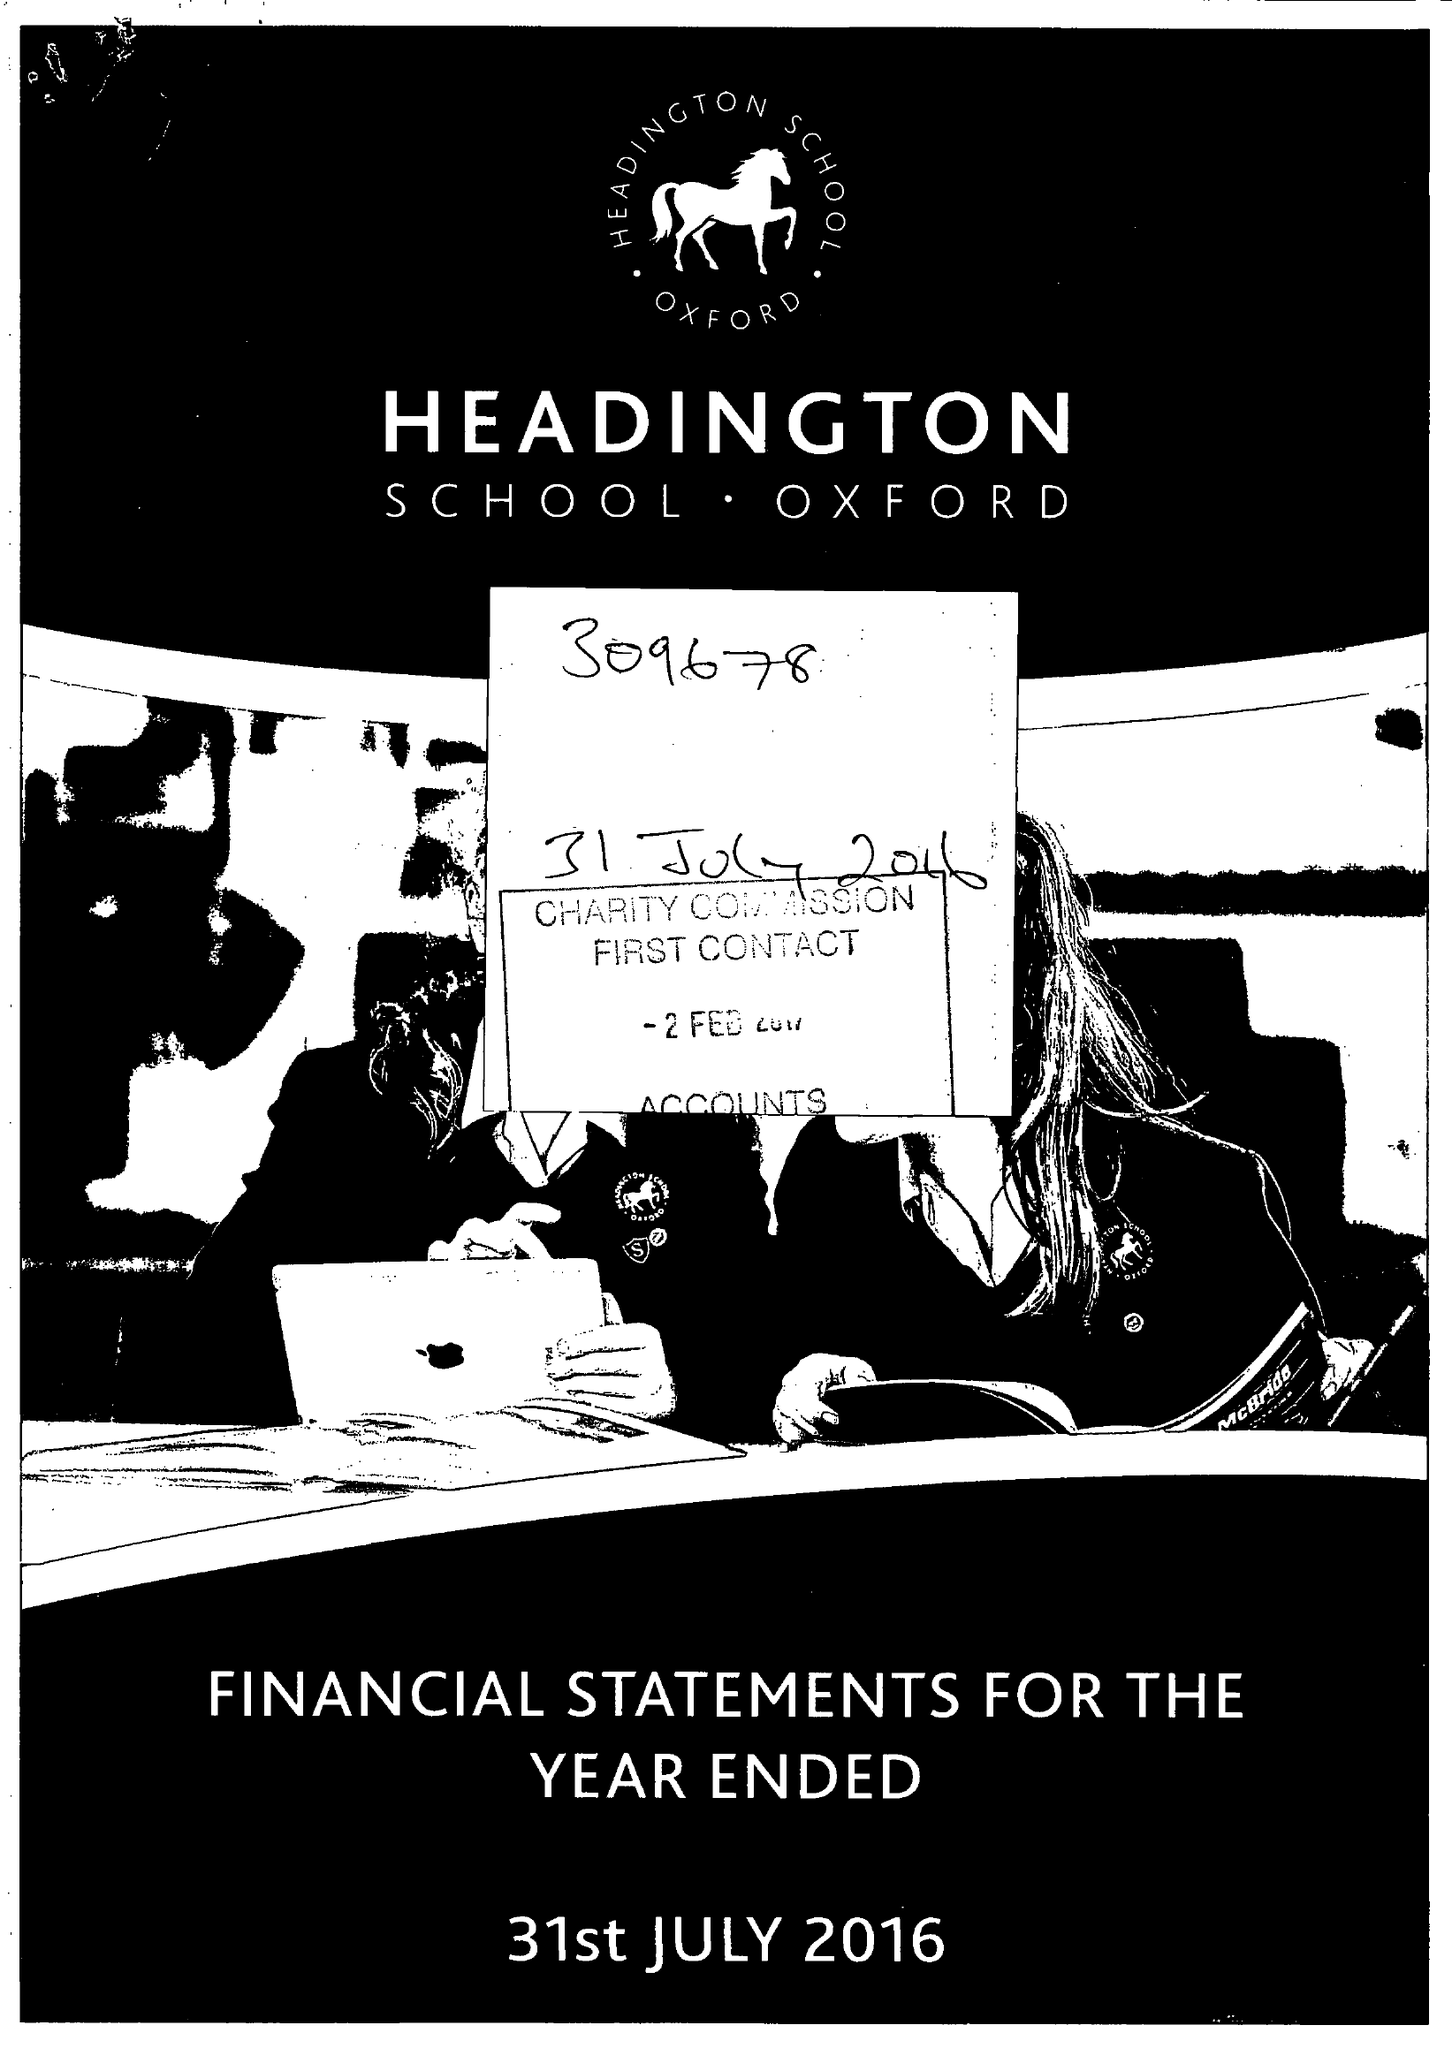What is the value for the income_annually_in_british_pounds?
Answer the question using a single word or phrase. 20344587.00 